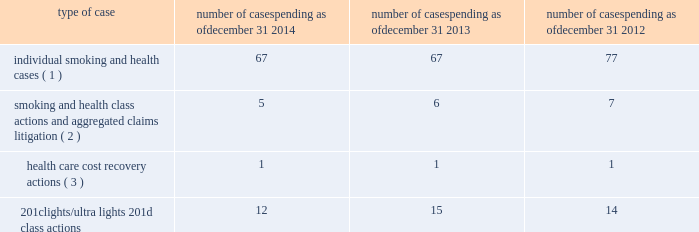Cases ; ( ii ) management is unable to estimate the possible loss or range of loss that could result from an unfavorable outcome in any of the pending tobacco-related cases ; and ( iii ) accordingly , management has not provided any amounts in the consolidated financial statements for unfavorable outcomes , if any .
Legal defense costs are expensed as incurred .
Altria group , inc .
And its subsidiaries have achieved substantial success in managing litigation .
Nevertheless , litigation is subject to uncertainty and significant challenges remain .
It is possible that the consolidated results of operations , cash flows or financial position of altria group , inc. , or one or more of its subsidiaries , could be materially affected in a particular fiscal quarter or fiscal year by an unfavorable outcome or settlement of certain pending litigation .
Altria group , inc .
And each of its subsidiaries named as a defendant believe , and each has been so advised by counsel handling the respective cases , that it has valid defenses to the litigation pending against it , as well as valid bases for appeal of adverse verdicts .
Each of the companies has defended , and will continue to defend , vigorously against litigation challenges .
However , altria group , inc .
And its subsidiaries may enter into settlement discussions in particular cases if they believe it is in the best interests of altria group , inc .
To do so .
Overview of altria group , inc .
And/or pm usa tobacco-related litigation types and number of cases : claims related to tobacco products generally fall within the following categories : ( i ) smoking and health cases alleging personal injury brought on behalf of individual plaintiffs ; ( ii ) smoking and health cases primarily alleging personal injury or seeking court- supervised programs for ongoing medical monitoring and purporting to be brought on behalf of a class of individual plaintiffs , including cases in which the aggregated claims of a number of individual plaintiffs are to be tried in a single proceeding ; ( iii ) health care cost recovery cases brought by governmental ( both domestic and foreign ) plaintiffs seeking reimbursement for health care expenditures allegedly caused by cigarette smoking and/or disgorgement of profits ; ( iv ) class action suits alleging that the uses of the terms 201clights 201d and 201cultra lights 201d constitute deceptive and unfair trade practices , common law or statutory fraud , unjust enrichment , breach of warranty or violations of the racketeer influenced and corrupt organizations act ( 201crico 201d ) ; and ( v ) other tobacco- related litigation described below .
Plaintiffs 2019 theories of recovery and the defenses raised in pending smoking and health , health care cost recovery and 201clights/ultra lights 201d cases are discussed below .
The table below lists the number of certain tobacco-related cases pending in the united states against pm usa and , in some instances , altria group , inc .
As of december 31 , 2014 , december 31 , 2013 and december 31 , 2012 .
Type of case number of cases pending as of december 31 , 2014 number of cases pending as of december 31 , 2013 number of cases pending as of december 31 , 2012 individual smoking and health cases ( 1 ) 67 67 77 smoking and health class actions and aggregated claims litigation ( 2 ) 5 6 7 health care cost recovery actions ( 3 ) 1 1 1 .
( 1 ) does not include 2558 cases brought by flight attendants seeking compensatory damages for personal injuries allegedly caused by exposure to environmental tobacco smoke ( 201cets 201d ) .
The flight attendants allege that they are members of an ets smoking and health class action in florida , which was settled in 1997 ( broin ) .
The terms of the court-approved settlement in that case allow class members to file individual lawsuits seeking compensatory damages , but prohibit them from seeking punitive damages .
Also , does not include individual smoking and health cases brought by or on behalf of plaintiffs in florida state and federal courts following the decertification of the engle case ( discussed below in smoking and health litigation - engle class action ) .
( 2 ) includes as one case the 600 civil actions ( of which 346 were actions against pm usa ) that were to be tried in a single proceeding in west virginia ( in re : tobacco litigation ) .
The west virginia supreme court of appeals has ruled that the united states constitution did not preclude a trial in two phases in this case .
Issues related to defendants 2019 conduct and whether punitive damages are permissible were tried in the first phase .
Trial in the first phase of this case began in april 2013 .
In may 2013 , the jury returned a verdict in favor of defendants on the claims for design defect , negligence , failure to warn , breach of warranty , and concealment and declined to find that the defendants 2019 conduct warranted punitive damages .
Plaintiffs prevailed on their claim that ventilated filter cigarettes should have included use instructions for the period 1964 - 1969 .
The second phase , if any , will consist of individual trials to determine liability and compensatory damages on that claim only .
In august 2013 , the trial court denied all post-trial motions .
The trial court entered final judgment in october 2013 and , in november 2013 , plaintiffs filed their notice of appeal to the west virginia supreme court of appeals .
On november 3 , 2014 , the west virginia supreme court of appeals affirmed the final judgment .
Plaintiffs filed a petition for rehearing with the west virginia supreme court of appeals , which the court denied on january 8 , 2015 .
( 3 ) see health care cost recovery litigation - federal government 2019s lawsuit below .
Altria group , inc .
And subsidiaries notes to consolidated financial statements _________________________ altria_mdc_2014form10k_nolinks_crops.pdf 68 2/25/15 5:56 pm .
What is the total tobacco-related cases pending in the united states as of december 31 , 2013? 
Computations: (((67 + 6) + 1) + 15)
Answer: 89.0. 